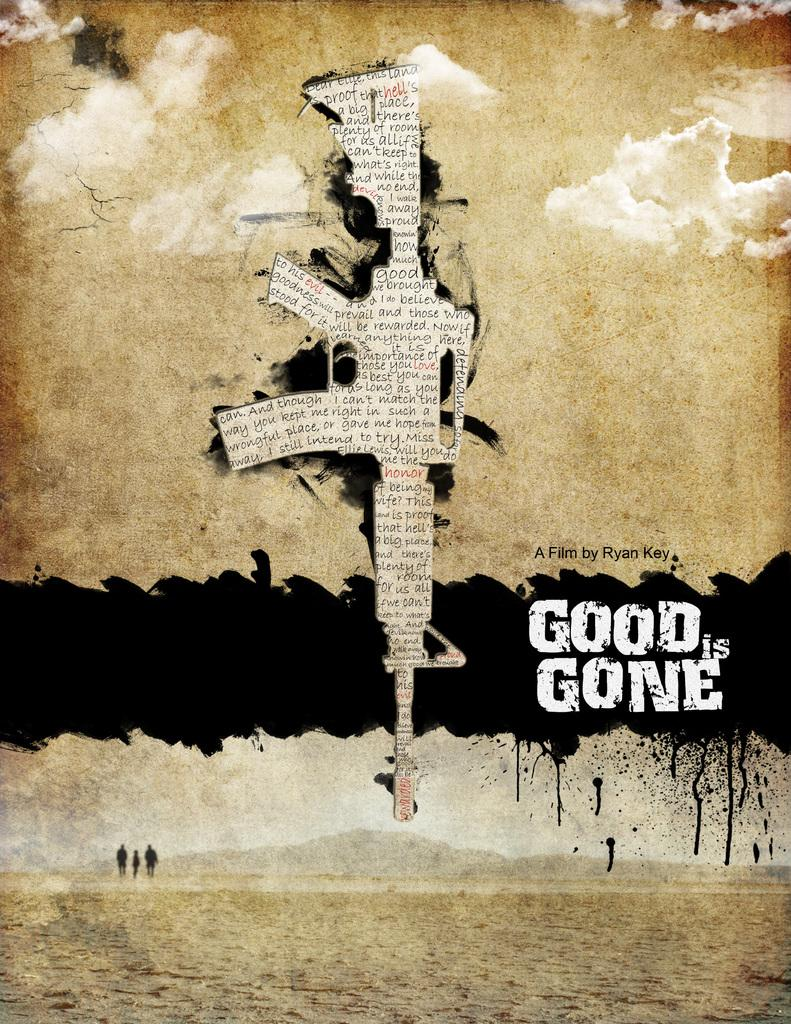<image>
Give a short and clear explanation of the subsequent image. The film cover where three people are walking for Good is Gone. 